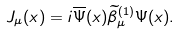<formula> <loc_0><loc_0><loc_500><loc_500>J _ { \mu } ( x ) = i \overline { \Psi } ( x ) \widetilde { \beta } _ { \mu } ^ { ( 1 ) } \Psi ( x ) .</formula> 